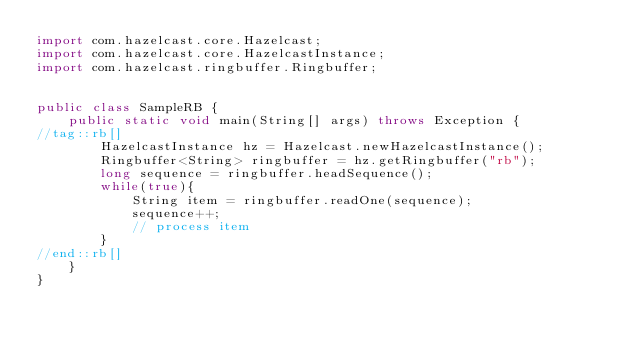<code> <loc_0><loc_0><loc_500><loc_500><_Java_>import com.hazelcast.core.Hazelcast;
import com.hazelcast.core.HazelcastInstance;
import com.hazelcast.ringbuffer.Ringbuffer;


public class SampleRB {
    public static void main(String[] args) throws Exception {
//tag::rb[]
        HazelcastInstance hz = Hazelcast.newHazelcastInstance();
        Ringbuffer<String> ringbuffer = hz.getRingbuffer("rb");
        long sequence = ringbuffer.headSequence();
        while(true){
            String item = ringbuffer.readOne(sequence);
            sequence++;
            // process item
        }
//end::rb[]
    }
}
</code> 